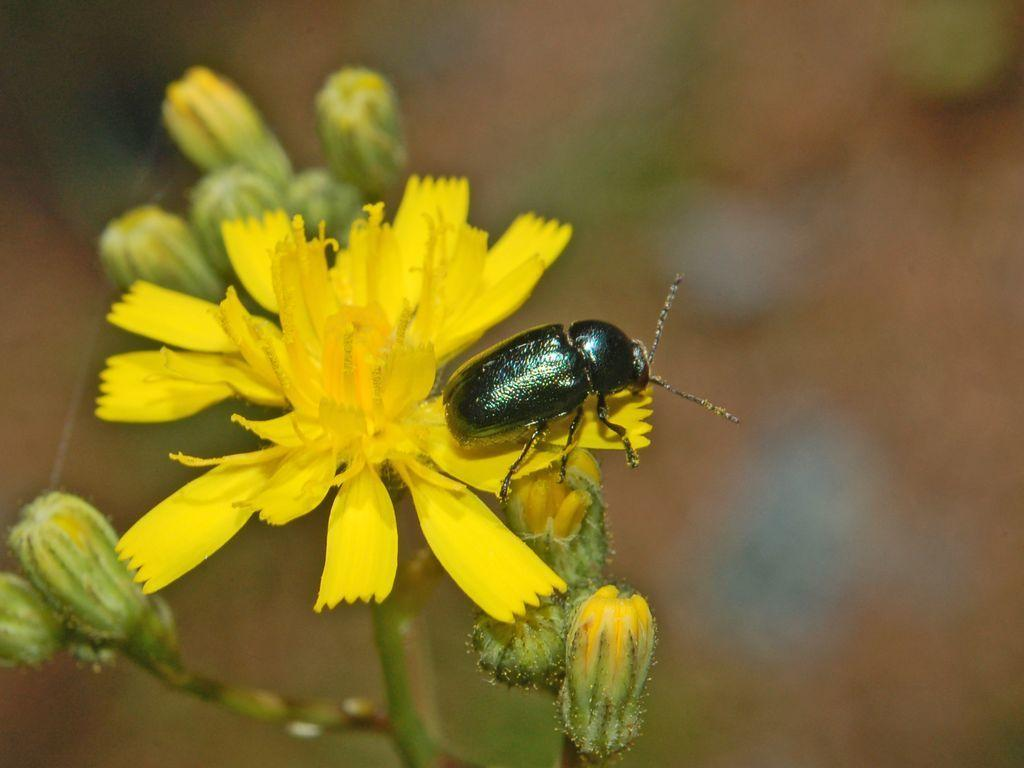What is on the flower in the image? There is an insect on a flower in the image. What stage of growth are the other flowers in the image? There are buds visible in the image. What color is the flower with the insect? The flower is yellow in color. What type of furniture is visible in the image? There is no furniture present in the image; it features a flower with an insect and buds. Can you tell me how many bananas are on the flower in the image? There are no bananas present in the image; it features a flower with an insect and buds. 